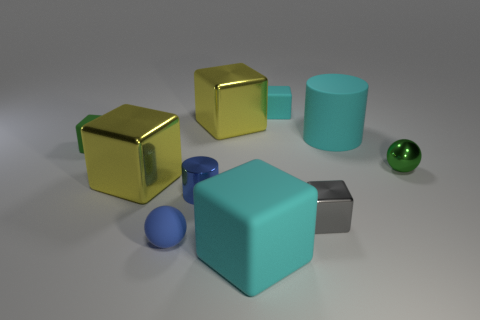Subtract all red cylinders. How many yellow blocks are left? 2 Subtract all small matte cubes. How many cubes are left? 4 Subtract 2 blocks. How many blocks are left? 4 Subtract all yellow blocks. How many blocks are left? 4 Subtract all cylinders. How many objects are left? 8 Subtract 0 red cubes. How many objects are left? 10 Subtract all yellow spheres. Subtract all purple blocks. How many spheres are left? 2 Subtract all blue things. Subtract all big cyan rubber objects. How many objects are left? 6 Add 2 cubes. How many cubes are left? 8 Add 7 tiny green spheres. How many tiny green spheres exist? 8 